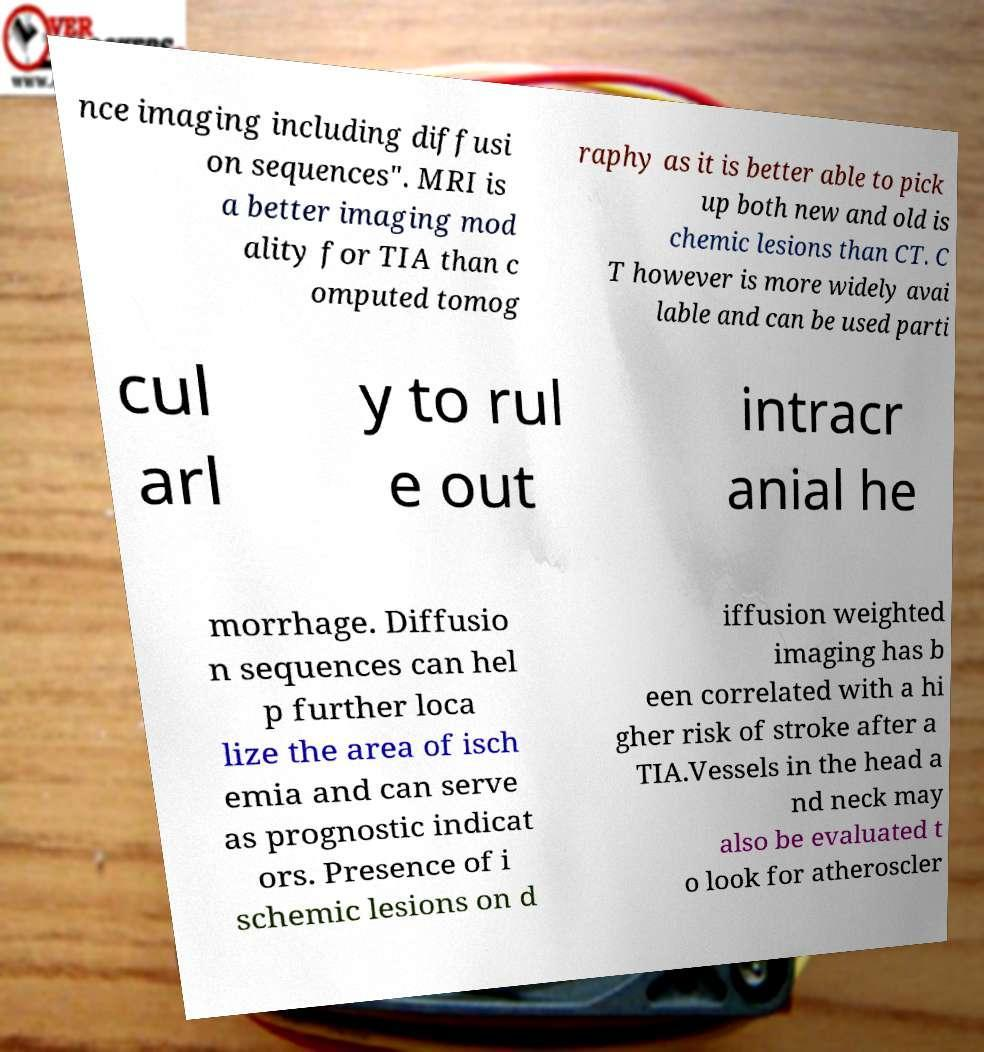Could you extract and type out the text from this image? nce imaging including diffusi on sequences". MRI is a better imaging mod ality for TIA than c omputed tomog raphy as it is better able to pick up both new and old is chemic lesions than CT. C T however is more widely avai lable and can be used parti cul arl y to rul e out intracr anial he morrhage. Diffusio n sequences can hel p further loca lize the area of isch emia and can serve as prognostic indicat ors. Presence of i schemic lesions on d iffusion weighted imaging has b een correlated with a hi gher risk of stroke after a TIA.Vessels in the head a nd neck may also be evaluated t o look for atheroscler 